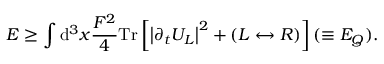Convert formula to latex. <formula><loc_0><loc_0><loc_500><loc_500>E \geq \int d ^ { 3 } x { \frac { F ^ { 2 } } { 4 } } T r \left [ \left | \partial _ { t } U _ { L } \right | ^ { 2 } + \left ( L \leftrightarrow R \right ) \right ] ( \equiv E _ { Q } ) .</formula> 